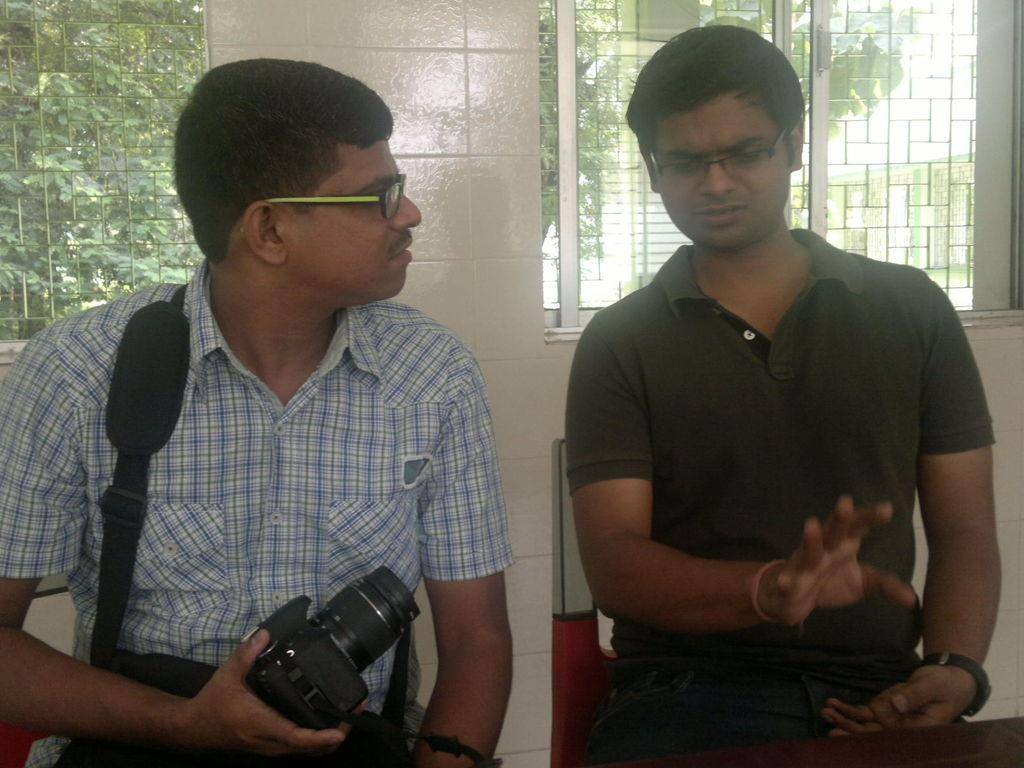How many people are in the image? There are two people in the image. What are the two people doing in the image? The two people are sitting on a chair. Can you describe one of the people in the image? One of the people is a man, and he is wearing a checkered shirt. What is the man holding in the image? The man is holding a camera. What can be seen in the background of the image? There is a wall and a window in the background of the image? How many cakes are on the man's knee in the image? There are no cakes on the man's knee in the image. Can you tell me what type of train is passing by in the image? There is no train present in the image. 